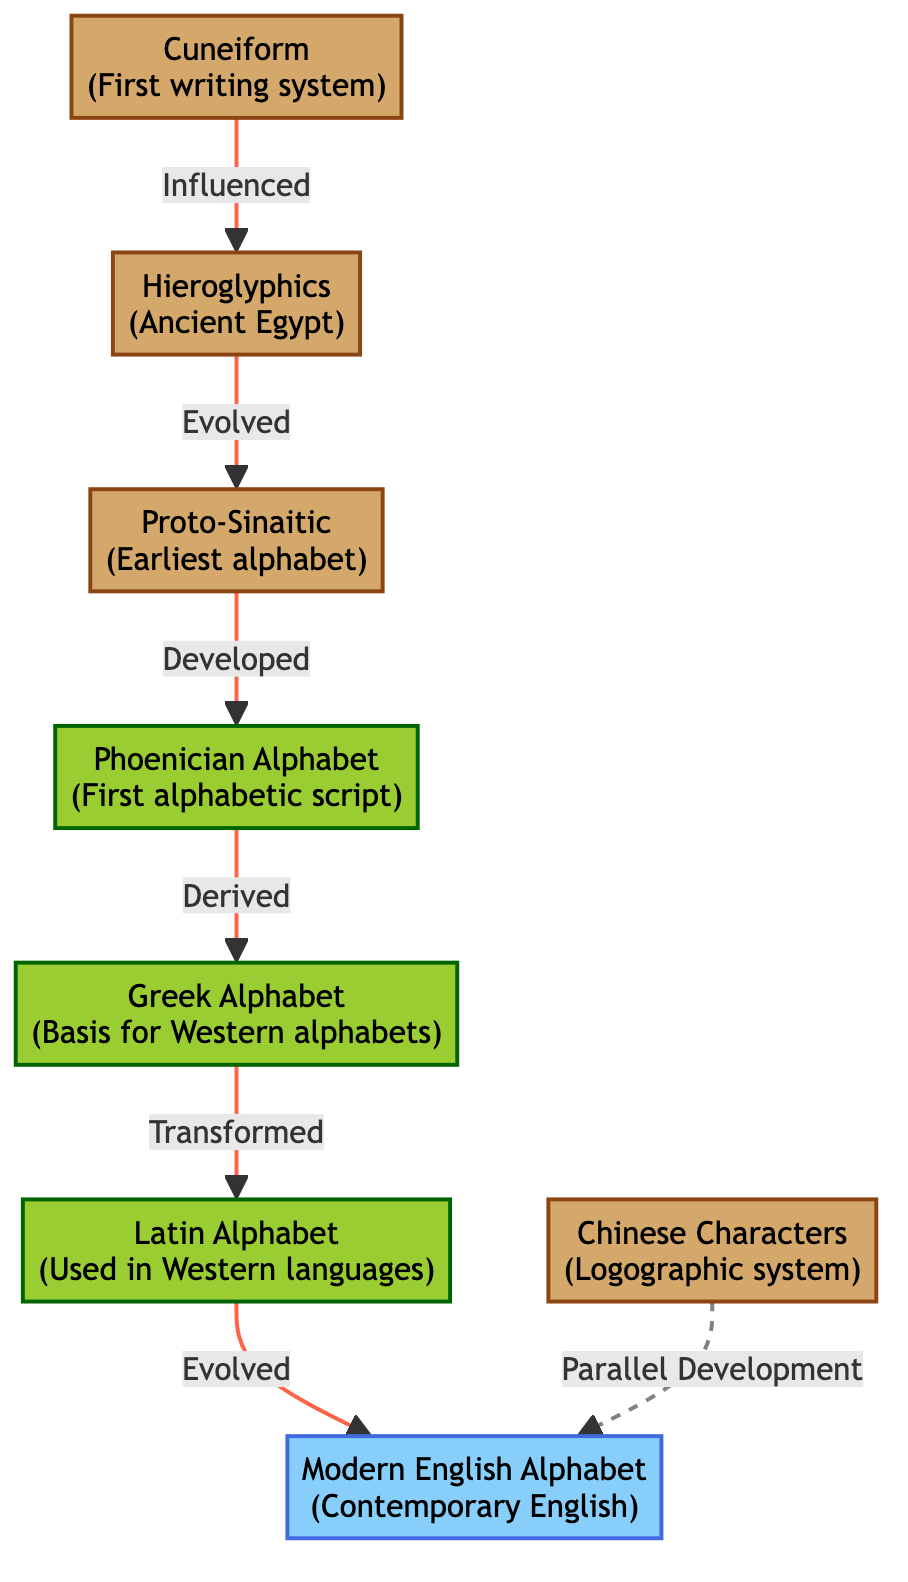What is the first writing system listed in the diagram? The diagram identifies "Cuneiform" as the first writing system. This is indicated by its label in the diagram.
Answer: Cuneiform Which writing system is considered the basis for Western alphabets? The diagram indicates that "Greek Alphabet" is considered the basis for Western alphabets as labeled in the diagram.
Answer: Greek Alphabet How many ancient writing systems are shown in the diagram? By counting the systems labeled in the ancient category, there are four: Cuneiform, Hieroglyphics, Proto-Sinaitic, and Chinese Characters.
Answer: 4 What is the relationship between Proto-Sinaitic and Phoenician in the diagram? The diagram shows that Proto-Sinaitic developed into the Phoenician Alphabet, represented by a direct connection between the two nodes with the label "Developed."
Answer: Developed What flow connects the Latin Alphabet to Modern English? The diagram shows that the Latin Alphabet evolved into the Modern English Alphabet, represented by a direct connection labeled "Evolved."
Answer: Evolved Which writing system has a dashed line indicating a parallel development? The diagram shows a dashed line connecting Chinese Characters to Modern English, which indicates a parallel development relationship.
Answer: Chinese Characters How many total nodes are present in the diagram? Adding together all writing systems and their relationships, there are a total of eight nodes represented in the diagram, counting all labeled writing systems.
Answer: 8 What is the last writing system mentioned in the flow of the diagram? The diagram indicates that "Modern English" is the last writing system mentioned as it appears as the final node without any subsequent flow leading to another system.
Answer: Modern English 